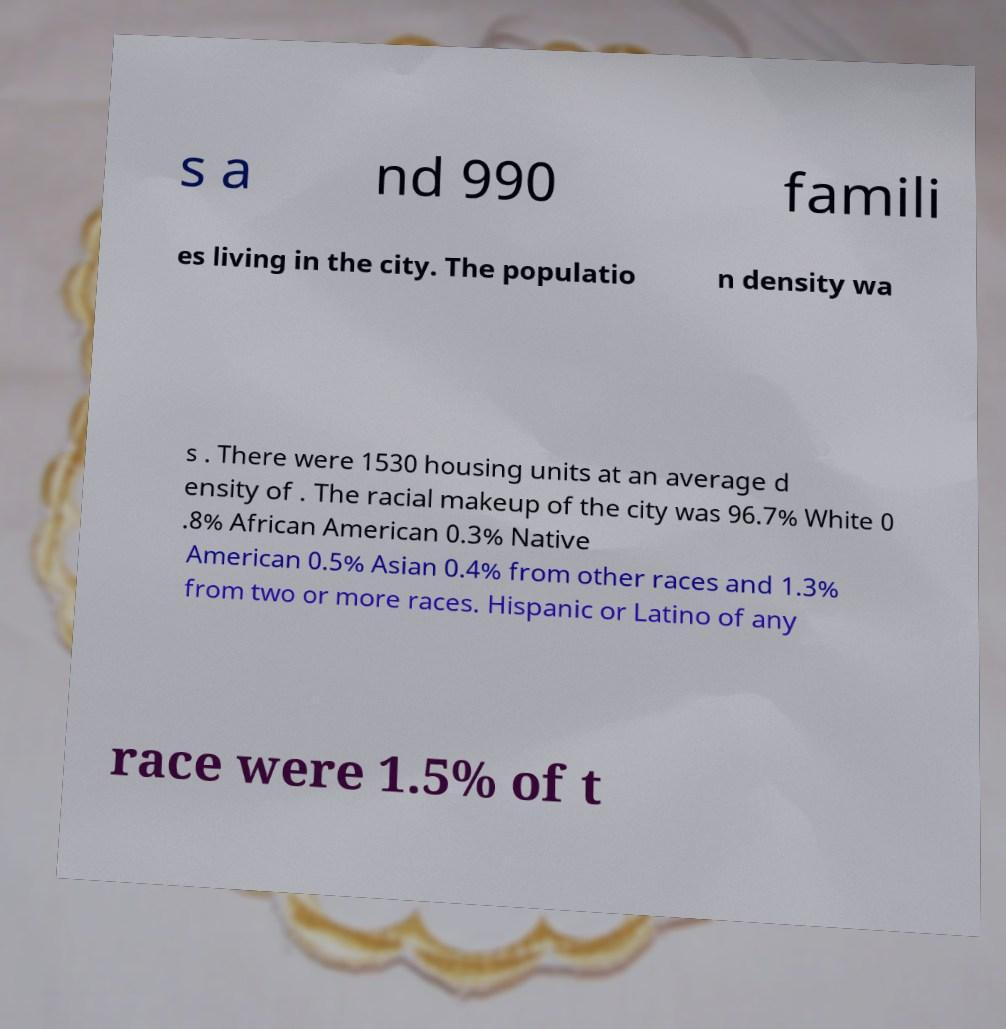Could you assist in decoding the text presented in this image and type it out clearly? s a nd 990 famili es living in the city. The populatio n density wa s . There were 1530 housing units at an average d ensity of . The racial makeup of the city was 96.7% White 0 .8% African American 0.3% Native American 0.5% Asian 0.4% from other races and 1.3% from two or more races. Hispanic or Latino of any race were 1.5% of t 